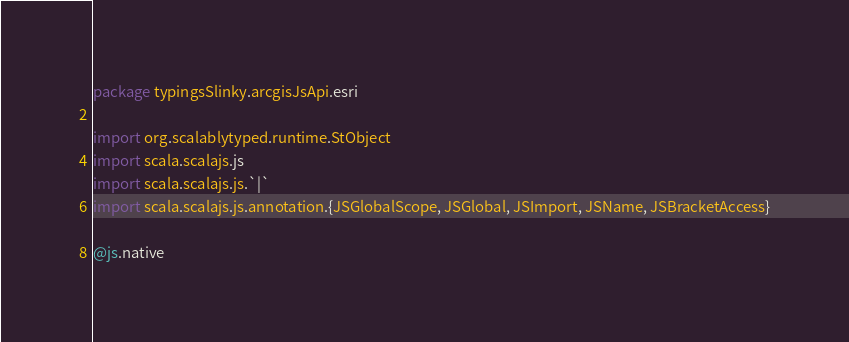<code> <loc_0><loc_0><loc_500><loc_500><_Scala_>package typingsSlinky.arcgisJsApi.esri

import org.scalablytyped.runtime.StObject
import scala.scalajs.js
import scala.scalajs.js.`|`
import scala.scalajs.js.annotation.{JSGlobalScope, JSGlobal, JSImport, JSName, JSBracketAccess}

@js.native</code> 